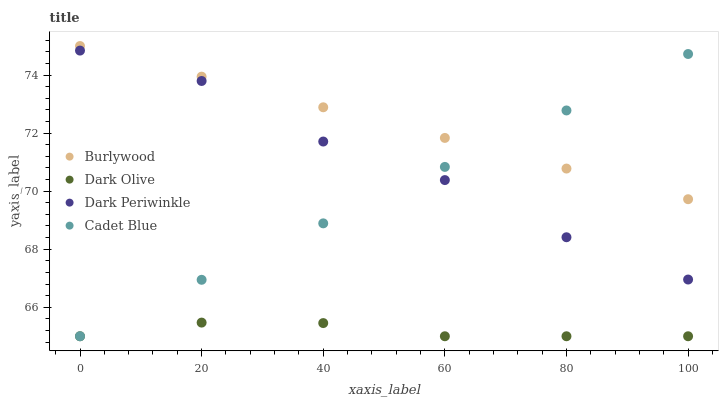Does Dark Olive have the minimum area under the curve?
Answer yes or no. Yes. Does Burlywood have the maximum area under the curve?
Answer yes or no. Yes. Does Cadet Blue have the minimum area under the curve?
Answer yes or no. No. Does Cadet Blue have the maximum area under the curve?
Answer yes or no. No. Is Cadet Blue the smoothest?
Answer yes or no. Yes. Is Dark Periwinkle the roughest?
Answer yes or no. Yes. Is Dark Olive the smoothest?
Answer yes or no. No. Is Dark Olive the roughest?
Answer yes or no. No. Does Dark Olive have the lowest value?
Answer yes or no. Yes. Does Dark Periwinkle have the lowest value?
Answer yes or no. No. Does Burlywood have the highest value?
Answer yes or no. Yes. Does Cadet Blue have the highest value?
Answer yes or no. No. Is Dark Olive less than Dark Periwinkle?
Answer yes or no. Yes. Is Burlywood greater than Dark Periwinkle?
Answer yes or no. Yes. Does Cadet Blue intersect Dark Periwinkle?
Answer yes or no. Yes. Is Cadet Blue less than Dark Periwinkle?
Answer yes or no. No. Is Cadet Blue greater than Dark Periwinkle?
Answer yes or no. No. Does Dark Olive intersect Dark Periwinkle?
Answer yes or no. No. 